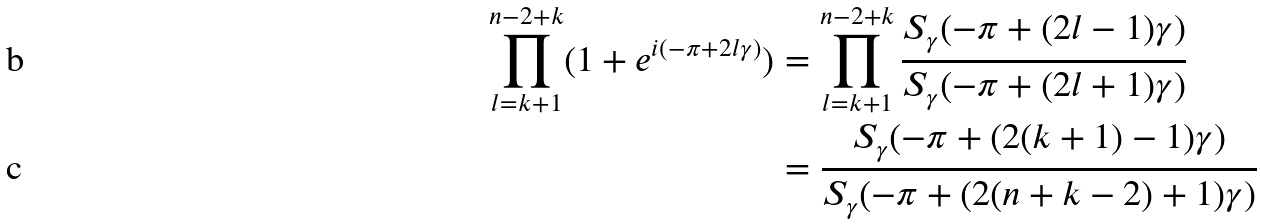<formula> <loc_0><loc_0><loc_500><loc_500>\prod _ { l = k + 1 } ^ { n - 2 + k } ( 1 + e ^ { i ( - \pi + 2 l \gamma ) } ) & = \prod _ { l = k + 1 } ^ { n - 2 + k } \frac { S _ { \gamma } ( - \pi + ( 2 l - 1 ) \gamma ) } { S _ { \gamma } ( - \pi + ( 2 l + 1 ) \gamma ) } \\ & = \frac { S _ { \gamma } ( - \pi + ( 2 ( k + 1 ) - 1 ) \gamma ) } { S _ { \gamma } ( - \pi + ( 2 ( n + k - 2 ) + 1 ) \gamma ) }</formula> 